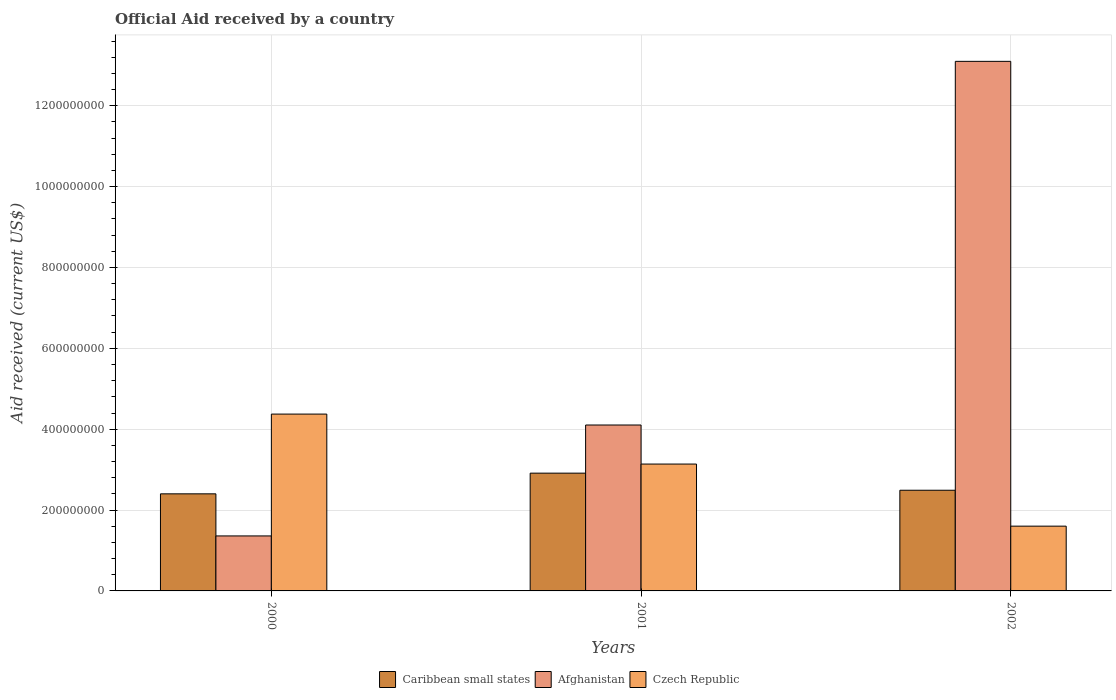Are the number of bars per tick equal to the number of legend labels?
Provide a succinct answer. Yes. How many bars are there on the 1st tick from the left?
Your answer should be very brief. 3. What is the net official aid received in Czech Republic in 2000?
Your answer should be very brief. 4.37e+08. Across all years, what is the maximum net official aid received in Afghanistan?
Your answer should be very brief. 1.31e+09. Across all years, what is the minimum net official aid received in Caribbean small states?
Ensure brevity in your answer.  2.40e+08. In which year was the net official aid received in Afghanistan maximum?
Offer a very short reply. 2002. In which year was the net official aid received in Afghanistan minimum?
Offer a very short reply. 2000. What is the total net official aid received in Afghanistan in the graph?
Give a very brief answer. 1.86e+09. What is the difference between the net official aid received in Czech Republic in 2000 and that in 2002?
Your response must be concise. 2.77e+08. What is the difference between the net official aid received in Czech Republic in 2000 and the net official aid received in Afghanistan in 2002?
Ensure brevity in your answer.  -8.72e+08. What is the average net official aid received in Caribbean small states per year?
Your answer should be compact. 2.60e+08. In the year 2001, what is the difference between the net official aid received in Afghanistan and net official aid received in Caribbean small states?
Provide a short and direct response. 1.19e+08. What is the ratio of the net official aid received in Czech Republic in 2000 to that in 2002?
Offer a very short reply. 2.73. Is the net official aid received in Afghanistan in 2001 less than that in 2002?
Keep it short and to the point. Yes. What is the difference between the highest and the second highest net official aid received in Caribbean small states?
Ensure brevity in your answer.  4.23e+07. What is the difference between the highest and the lowest net official aid received in Afghanistan?
Offer a very short reply. 1.17e+09. In how many years, is the net official aid received in Afghanistan greater than the average net official aid received in Afghanistan taken over all years?
Give a very brief answer. 1. What does the 2nd bar from the left in 2002 represents?
Your answer should be compact. Afghanistan. What does the 2nd bar from the right in 2000 represents?
Your answer should be compact. Afghanistan. Does the graph contain any zero values?
Provide a succinct answer. No. Does the graph contain grids?
Ensure brevity in your answer.  Yes. How many legend labels are there?
Offer a very short reply. 3. How are the legend labels stacked?
Ensure brevity in your answer.  Horizontal. What is the title of the graph?
Provide a succinct answer. Official Aid received by a country. Does "Suriname" appear as one of the legend labels in the graph?
Provide a short and direct response. No. What is the label or title of the Y-axis?
Make the answer very short. Aid received (current US$). What is the Aid received (current US$) in Caribbean small states in 2000?
Keep it short and to the point. 2.40e+08. What is the Aid received (current US$) of Afghanistan in 2000?
Your answer should be compact. 1.36e+08. What is the Aid received (current US$) of Czech Republic in 2000?
Make the answer very short. 4.37e+08. What is the Aid received (current US$) of Caribbean small states in 2001?
Offer a very short reply. 2.91e+08. What is the Aid received (current US$) of Afghanistan in 2001?
Make the answer very short. 4.10e+08. What is the Aid received (current US$) of Czech Republic in 2001?
Your answer should be compact. 3.14e+08. What is the Aid received (current US$) of Caribbean small states in 2002?
Offer a very short reply. 2.49e+08. What is the Aid received (current US$) of Afghanistan in 2002?
Your answer should be very brief. 1.31e+09. What is the Aid received (current US$) of Czech Republic in 2002?
Keep it short and to the point. 1.60e+08. Across all years, what is the maximum Aid received (current US$) in Caribbean small states?
Keep it short and to the point. 2.91e+08. Across all years, what is the maximum Aid received (current US$) in Afghanistan?
Provide a short and direct response. 1.31e+09. Across all years, what is the maximum Aid received (current US$) in Czech Republic?
Ensure brevity in your answer.  4.37e+08. Across all years, what is the minimum Aid received (current US$) in Caribbean small states?
Ensure brevity in your answer.  2.40e+08. Across all years, what is the minimum Aid received (current US$) of Afghanistan?
Your answer should be very brief. 1.36e+08. Across all years, what is the minimum Aid received (current US$) in Czech Republic?
Your response must be concise. 1.60e+08. What is the total Aid received (current US$) in Caribbean small states in the graph?
Offer a terse response. 7.80e+08. What is the total Aid received (current US$) in Afghanistan in the graph?
Provide a succinct answer. 1.86e+09. What is the total Aid received (current US$) in Czech Republic in the graph?
Your answer should be very brief. 9.11e+08. What is the difference between the Aid received (current US$) in Caribbean small states in 2000 and that in 2001?
Ensure brevity in your answer.  -5.12e+07. What is the difference between the Aid received (current US$) in Afghanistan in 2000 and that in 2001?
Your answer should be compact. -2.74e+08. What is the difference between the Aid received (current US$) in Czech Republic in 2000 and that in 2001?
Provide a short and direct response. 1.24e+08. What is the difference between the Aid received (current US$) in Caribbean small states in 2000 and that in 2002?
Keep it short and to the point. -8.88e+06. What is the difference between the Aid received (current US$) of Afghanistan in 2000 and that in 2002?
Keep it short and to the point. -1.17e+09. What is the difference between the Aid received (current US$) of Czech Republic in 2000 and that in 2002?
Your answer should be compact. 2.77e+08. What is the difference between the Aid received (current US$) in Caribbean small states in 2001 and that in 2002?
Provide a succinct answer. 4.23e+07. What is the difference between the Aid received (current US$) of Afghanistan in 2001 and that in 2002?
Give a very brief answer. -8.99e+08. What is the difference between the Aid received (current US$) in Czech Republic in 2001 and that in 2002?
Keep it short and to the point. 1.54e+08. What is the difference between the Aid received (current US$) in Caribbean small states in 2000 and the Aid received (current US$) in Afghanistan in 2001?
Your answer should be compact. -1.70e+08. What is the difference between the Aid received (current US$) of Caribbean small states in 2000 and the Aid received (current US$) of Czech Republic in 2001?
Make the answer very short. -7.37e+07. What is the difference between the Aid received (current US$) in Afghanistan in 2000 and the Aid received (current US$) in Czech Republic in 2001?
Make the answer very short. -1.78e+08. What is the difference between the Aid received (current US$) in Caribbean small states in 2000 and the Aid received (current US$) in Afghanistan in 2002?
Offer a terse response. -1.07e+09. What is the difference between the Aid received (current US$) of Caribbean small states in 2000 and the Aid received (current US$) of Czech Republic in 2002?
Provide a succinct answer. 7.99e+07. What is the difference between the Aid received (current US$) in Afghanistan in 2000 and the Aid received (current US$) in Czech Republic in 2002?
Keep it short and to the point. -2.42e+07. What is the difference between the Aid received (current US$) of Caribbean small states in 2001 and the Aid received (current US$) of Afghanistan in 2002?
Your answer should be very brief. -1.02e+09. What is the difference between the Aid received (current US$) in Caribbean small states in 2001 and the Aid received (current US$) in Czech Republic in 2002?
Provide a short and direct response. 1.31e+08. What is the difference between the Aid received (current US$) in Afghanistan in 2001 and the Aid received (current US$) in Czech Republic in 2002?
Keep it short and to the point. 2.50e+08. What is the average Aid received (current US$) of Caribbean small states per year?
Give a very brief answer. 2.60e+08. What is the average Aid received (current US$) in Afghanistan per year?
Offer a terse response. 6.19e+08. What is the average Aid received (current US$) in Czech Republic per year?
Provide a succinct answer. 3.04e+08. In the year 2000, what is the difference between the Aid received (current US$) in Caribbean small states and Aid received (current US$) in Afghanistan?
Give a very brief answer. 1.04e+08. In the year 2000, what is the difference between the Aid received (current US$) in Caribbean small states and Aid received (current US$) in Czech Republic?
Provide a short and direct response. -1.97e+08. In the year 2000, what is the difference between the Aid received (current US$) in Afghanistan and Aid received (current US$) in Czech Republic?
Offer a terse response. -3.01e+08. In the year 2001, what is the difference between the Aid received (current US$) of Caribbean small states and Aid received (current US$) of Afghanistan?
Make the answer very short. -1.19e+08. In the year 2001, what is the difference between the Aid received (current US$) of Caribbean small states and Aid received (current US$) of Czech Republic?
Your answer should be very brief. -2.25e+07. In the year 2001, what is the difference between the Aid received (current US$) in Afghanistan and Aid received (current US$) in Czech Republic?
Make the answer very short. 9.66e+07. In the year 2002, what is the difference between the Aid received (current US$) in Caribbean small states and Aid received (current US$) in Afghanistan?
Provide a short and direct response. -1.06e+09. In the year 2002, what is the difference between the Aid received (current US$) of Caribbean small states and Aid received (current US$) of Czech Republic?
Offer a very short reply. 8.88e+07. In the year 2002, what is the difference between the Aid received (current US$) of Afghanistan and Aid received (current US$) of Czech Republic?
Provide a succinct answer. 1.15e+09. What is the ratio of the Aid received (current US$) in Caribbean small states in 2000 to that in 2001?
Ensure brevity in your answer.  0.82. What is the ratio of the Aid received (current US$) in Afghanistan in 2000 to that in 2001?
Provide a succinct answer. 0.33. What is the ratio of the Aid received (current US$) of Czech Republic in 2000 to that in 2001?
Provide a succinct answer. 1.39. What is the ratio of the Aid received (current US$) of Caribbean small states in 2000 to that in 2002?
Your answer should be very brief. 0.96. What is the ratio of the Aid received (current US$) of Afghanistan in 2000 to that in 2002?
Your answer should be very brief. 0.1. What is the ratio of the Aid received (current US$) of Czech Republic in 2000 to that in 2002?
Give a very brief answer. 2.73. What is the ratio of the Aid received (current US$) of Caribbean small states in 2001 to that in 2002?
Your answer should be very brief. 1.17. What is the ratio of the Aid received (current US$) in Afghanistan in 2001 to that in 2002?
Provide a short and direct response. 0.31. What is the ratio of the Aid received (current US$) of Czech Republic in 2001 to that in 2002?
Your answer should be very brief. 1.96. What is the difference between the highest and the second highest Aid received (current US$) in Caribbean small states?
Keep it short and to the point. 4.23e+07. What is the difference between the highest and the second highest Aid received (current US$) of Afghanistan?
Your answer should be compact. 8.99e+08. What is the difference between the highest and the second highest Aid received (current US$) of Czech Republic?
Your answer should be compact. 1.24e+08. What is the difference between the highest and the lowest Aid received (current US$) in Caribbean small states?
Ensure brevity in your answer.  5.12e+07. What is the difference between the highest and the lowest Aid received (current US$) of Afghanistan?
Offer a very short reply. 1.17e+09. What is the difference between the highest and the lowest Aid received (current US$) of Czech Republic?
Provide a short and direct response. 2.77e+08. 